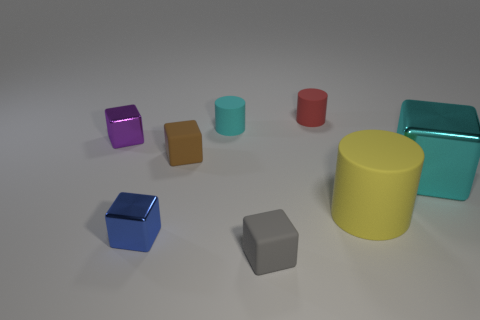Add 2 rubber cylinders. How many objects exist? 10 Subtract all gray matte blocks. How many blocks are left? 4 Subtract all blue cubes. How many cubes are left? 4 Subtract 1 cylinders. How many cylinders are left? 2 Subtract all cubes. How many objects are left? 3 Subtract all blue cubes. Subtract all red spheres. How many cubes are left? 4 Subtract 0 green cylinders. How many objects are left? 8 Subtract all yellow cylinders. How many purple cubes are left? 1 Subtract all large matte things. Subtract all tiny green shiny cylinders. How many objects are left? 7 Add 3 tiny red cylinders. How many tiny red cylinders are left? 4 